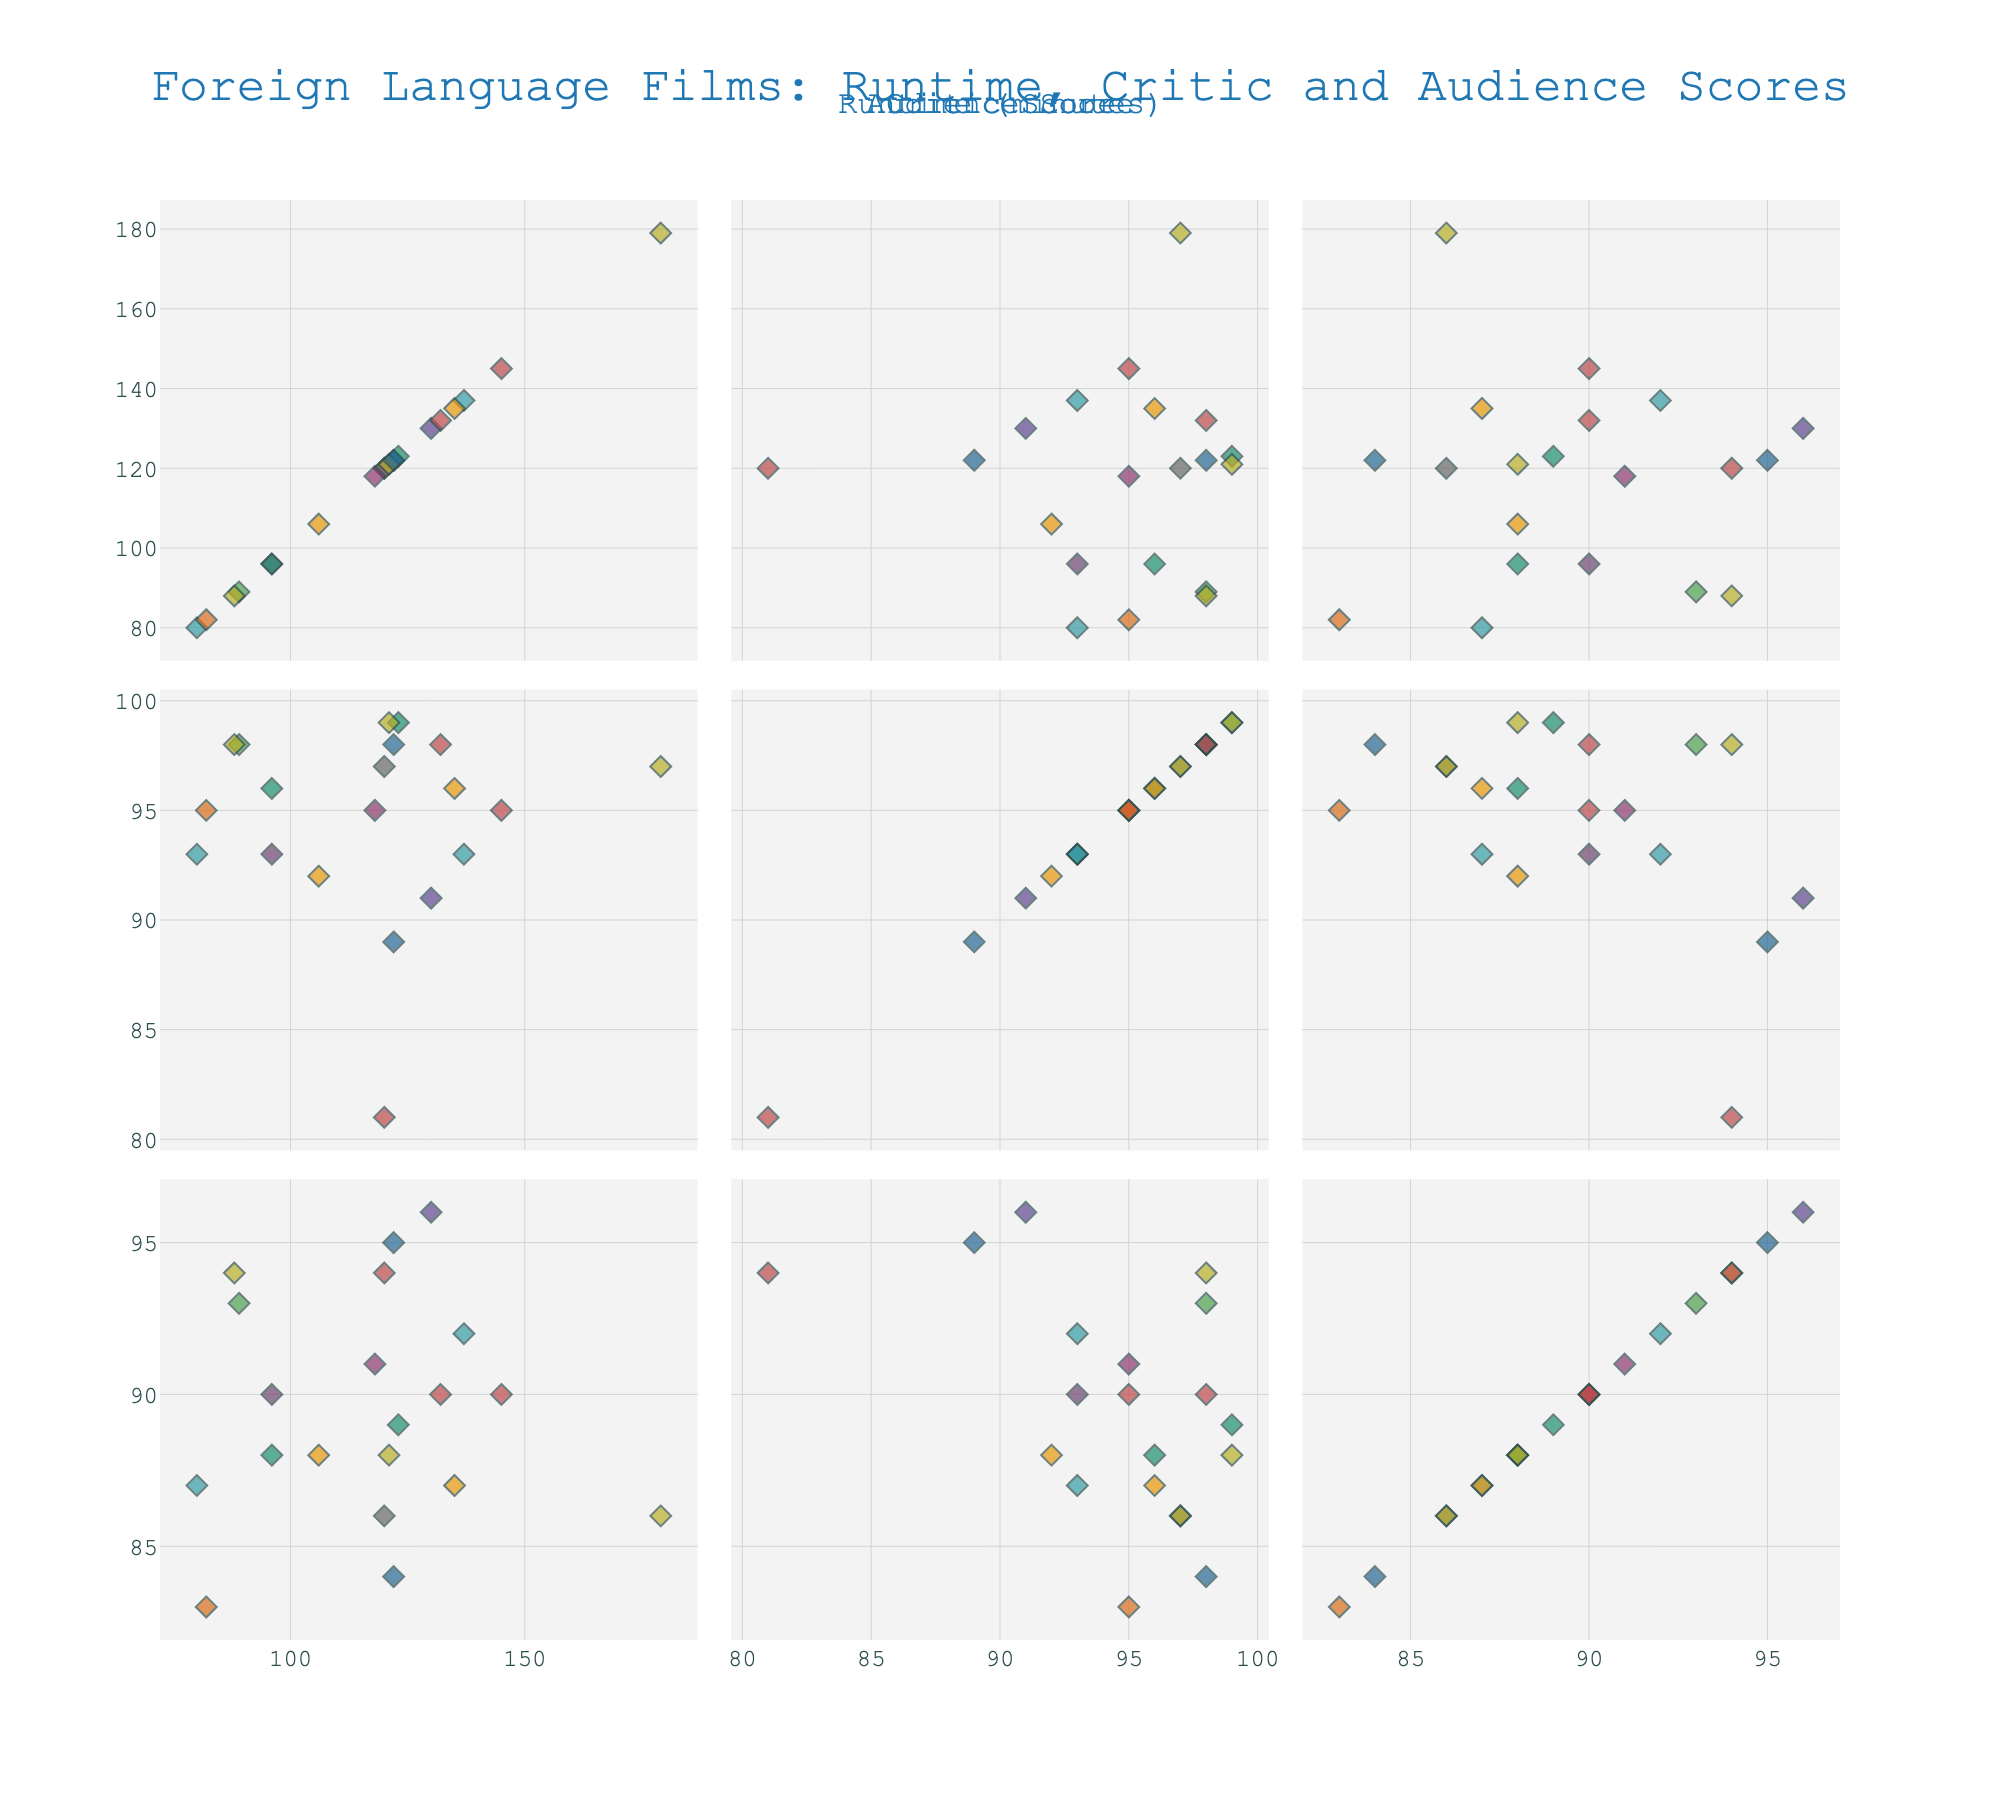What is the title of the figure? The title is usually displayed at the top center of the figure.
Answer: Foreign Language Films: Runtime, Critic and Audience Scores How many films from Japan are included in the dataset? Identify the number of data points labeled “Japan” in the scatter plots.
Answer: 3 Which film has the highest runtime? Look at the scatter plot where runtime is on the x-axis and identify the data point farthest to the right.
Answer: Drive My Car What are the critic and audience scores for the film 'Amélie'? Locate the data point for 'Amélie' using hover text in any of the scatter plots and read the Critic and Audience Scores.
Answer: 89 and 95 Which country has the most films listed? Count the data points for each country using the hover text in the scatter plots.
Answer: South Korea What is the median runtime of all the films? Arrange the runtimes in ascending order and find the middle value. Since there are 19 films, the median is the 10th value.
Answer: 120 minutes Is there a general trend between runtime and critic scores? Look at the scatter plot with runtime on the x-axis and critic score on the y-axis to see if there's an upward, downward, or no clear trend.
Answer: No clear trend Which film has the lowest audience score, and what is it? Look for the data point corresponding to the lowest value on the y-axis in a scatter plot where Audience Score is plotted.
Answer: Ida, 83 Do longer films generally receive better audience scores? Observe the scatter plot where runtime is on the x-axis and audience score is on the y-axis to identify any trend.
Answer: No strong correlation What is the total number of unique countries represented in the dataset? Count the distinct country names from the hover text in the scatter plots.
Answer: 12 